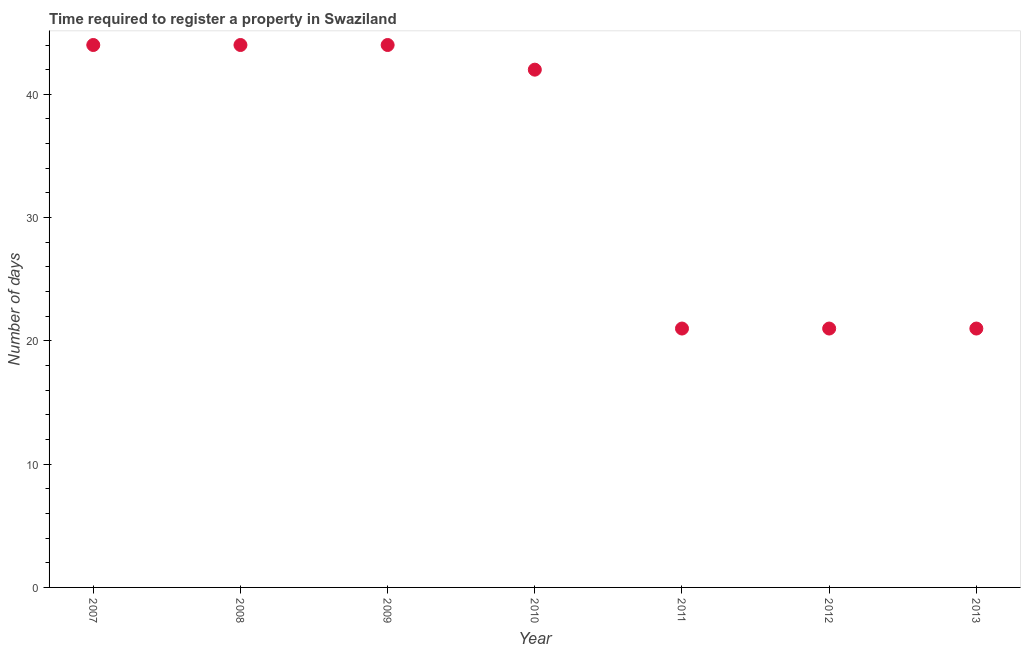What is the number of days required to register property in 2009?
Ensure brevity in your answer.  44. Across all years, what is the maximum number of days required to register property?
Give a very brief answer. 44. Across all years, what is the minimum number of days required to register property?
Make the answer very short. 21. What is the sum of the number of days required to register property?
Your answer should be compact. 237. What is the difference between the number of days required to register property in 2007 and 2013?
Keep it short and to the point. 23. What is the average number of days required to register property per year?
Your answer should be very brief. 33.86. What is the ratio of the number of days required to register property in 2011 to that in 2013?
Your answer should be compact. 1. Is the number of days required to register property in 2012 less than that in 2013?
Provide a short and direct response. No. What is the difference between the highest and the second highest number of days required to register property?
Your answer should be compact. 0. Is the sum of the number of days required to register property in 2009 and 2011 greater than the maximum number of days required to register property across all years?
Your answer should be very brief. Yes. What is the difference between the highest and the lowest number of days required to register property?
Your answer should be very brief. 23. In how many years, is the number of days required to register property greater than the average number of days required to register property taken over all years?
Keep it short and to the point. 4. Does the number of days required to register property monotonically increase over the years?
Make the answer very short. No. How many dotlines are there?
Provide a succinct answer. 1. Does the graph contain grids?
Provide a succinct answer. No. What is the title of the graph?
Ensure brevity in your answer.  Time required to register a property in Swaziland. What is the label or title of the X-axis?
Your answer should be compact. Year. What is the label or title of the Y-axis?
Your answer should be very brief. Number of days. What is the Number of days in 2008?
Your answer should be very brief. 44. What is the Number of days in 2009?
Offer a terse response. 44. What is the Number of days in 2010?
Provide a succinct answer. 42. What is the Number of days in 2013?
Ensure brevity in your answer.  21. What is the difference between the Number of days in 2007 and 2009?
Make the answer very short. 0. What is the difference between the Number of days in 2007 and 2010?
Offer a terse response. 2. What is the difference between the Number of days in 2007 and 2011?
Your answer should be compact. 23. What is the difference between the Number of days in 2007 and 2012?
Provide a succinct answer. 23. What is the difference between the Number of days in 2008 and 2009?
Your answer should be compact. 0. What is the difference between the Number of days in 2008 and 2010?
Your answer should be very brief. 2. What is the difference between the Number of days in 2008 and 2011?
Offer a very short reply. 23. What is the difference between the Number of days in 2008 and 2012?
Ensure brevity in your answer.  23. What is the difference between the Number of days in 2008 and 2013?
Your answer should be very brief. 23. What is the difference between the Number of days in 2009 and 2011?
Provide a succinct answer. 23. What is the difference between the Number of days in 2009 and 2012?
Provide a succinct answer. 23. What is the difference between the Number of days in 2010 and 2011?
Provide a short and direct response. 21. What is the difference between the Number of days in 2010 and 2012?
Ensure brevity in your answer.  21. What is the difference between the Number of days in 2010 and 2013?
Provide a short and direct response. 21. What is the difference between the Number of days in 2011 and 2013?
Your answer should be compact. 0. What is the ratio of the Number of days in 2007 to that in 2008?
Give a very brief answer. 1. What is the ratio of the Number of days in 2007 to that in 2010?
Ensure brevity in your answer.  1.05. What is the ratio of the Number of days in 2007 to that in 2011?
Offer a terse response. 2.1. What is the ratio of the Number of days in 2007 to that in 2012?
Make the answer very short. 2.1. What is the ratio of the Number of days in 2007 to that in 2013?
Provide a succinct answer. 2.1. What is the ratio of the Number of days in 2008 to that in 2009?
Give a very brief answer. 1. What is the ratio of the Number of days in 2008 to that in 2010?
Your answer should be compact. 1.05. What is the ratio of the Number of days in 2008 to that in 2011?
Your response must be concise. 2.1. What is the ratio of the Number of days in 2008 to that in 2012?
Your response must be concise. 2.1. What is the ratio of the Number of days in 2008 to that in 2013?
Provide a succinct answer. 2.1. What is the ratio of the Number of days in 2009 to that in 2010?
Your response must be concise. 1.05. What is the ratio of the Number of days in 2009 to that in 2011?
Keep it short and to the point. 2.1. What is the ratio of the Number of days in 2009 to that in 2012?
Your answer should be compact. 2.1. What is the ratio of the Number of days in 2009 to that in 2013?
Give a very brief answer. 2.1. What is the ratio of the Number of days in 2010 to that in 2011?
Your answer should be very brief. 2. What is the ratio of the Number of days in 2010 to that in 2012?
Make the answer very short. 2. What is the ratio of the Number of days in 2010 to that in 2013?
Offer a terse response. 2. 